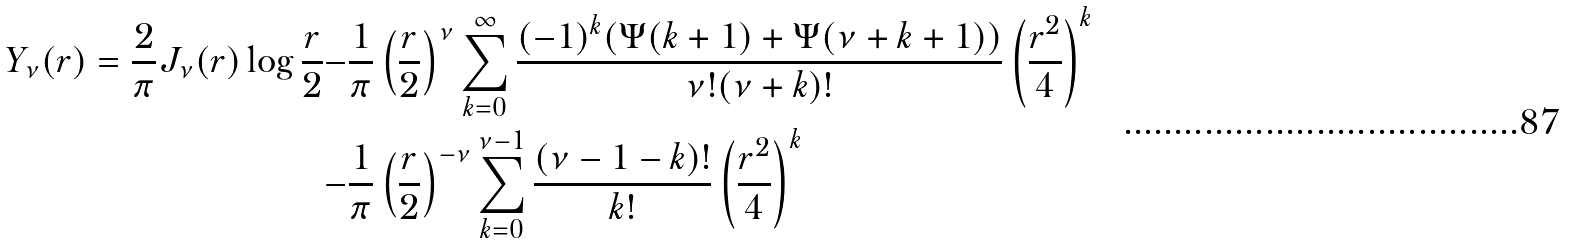<formula> <loc_0><loc_0><loc_500><loc_500>Y _ { \nu } ( r ) = \frac { 2 } { \pi } J _ { \nu } ( r ) \log \frac { r } { 2 } - & \frac { 1 } { \pi } \left ( \frac { r } { 2 } \right ) ^ { \nu } \sum _ { k = 0 } ^ { \infty } \frac { ( - 1 ) ^ { k } ( \Psi ( k + 1 ) + \Psi ( \nu + k + 1 ) ) } { \nu ! ( \nu + k ) ! } \left ( \frac { r ^ { 2 } } { 4 } \right ) ^ { k } \\ - & \frac { 1 } { \pi } \left ( \frac { r } { 2 } \right ) ^ { - \nu } \sum _ { k = 0 } ^ { \nu - 1 } \frac { ( \nu - 1 - k ) ! } { k ! } \left ( \frac { r ^ { 2 } } { 4 } \right ) ^ { k }</formula> 